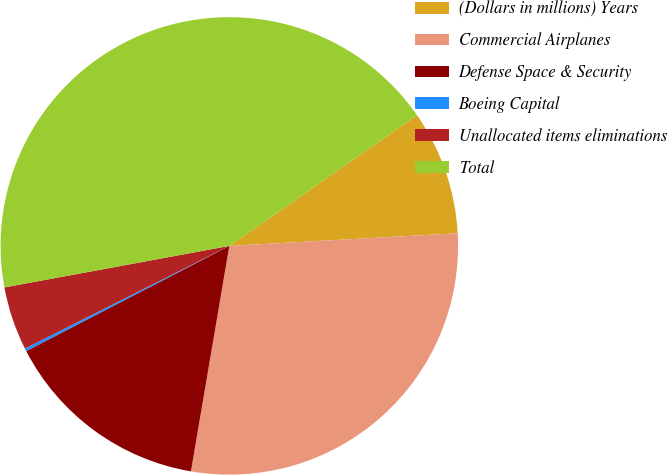Convert chart. <chart><loc_0><loc_0><loc_500><loc_500><pie_chart><fcel>(Dollars in millions) Years<fcel>Commercial Airplanes<fcel>Defense Space & Security<fcel>Boeing Capital<fcel>Unallocated items eliminations<fcel>Total<nl><fcel>8.8%<fcel>28.57%<fcel>14.71%<fcel>0.2%<fcel>4.5%<fcel>43.22%<nl></chart> 